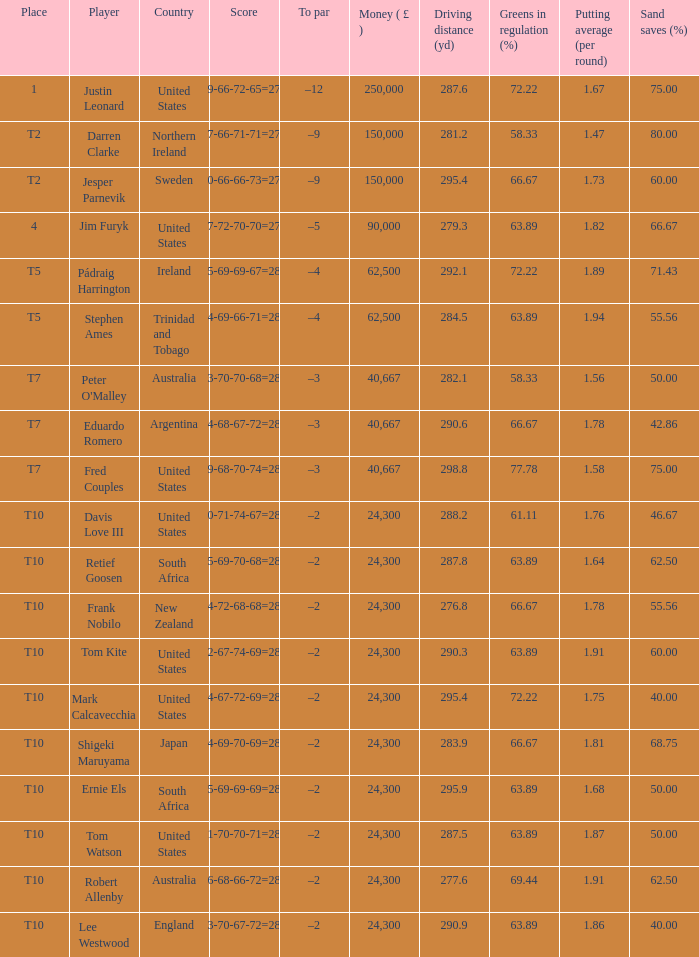What is the money won by Frank Nobilo? 1.0. Could you parse the entire table? {'header': ['Place', 'Player', 'Country', 'Score', 'To par', 'Money ( £ )', 'Driving distance (yd)', 'Greens in regulation (%)', 'Putting average (per round)', 'Sand saves (%)'], 'rows': [['1', 'Justin Leonard', 'United States', '69-66-72-65=272', '–12', '250,000', '287.6', '72.22', '1.67', '75.00'], ['T2', 'Darren Clarke', 'Northern Ireland', '67-66-71-71=275', '–9', '150,000', '281.2', '58.33', '1.47', '80.00'], ['T2', 'Jesper Parnevik', 'Sweden', '70-66-66-73=275', '–9', '150,000', '295.4', '66.67', '1.73', '60.00'], ['4', 'Jim Furyk', 'United States', '67-72-70-70=279', '–5', '90,000', '279.3', '63.89', '1.82', '66.67'], ['T5', 'Pádraig Harrington', 'Ireland', '75-69-69-67=280', '–4', '62,500', '292.1', '72.22', '1.89', '71.43'], ['T5', 'Stephen Ames', 'Trinidad and Tobago', '74-69-66-71=280', '–4', '62,500', '284.5', '63.89', '1.94', '55.56'], ['T7', "Peter O'Malley", 'Australia', '73-70-70-68=281', '–3', '40,667', '282.1', '58.33', '1.56', '50.00'], ['T7', 'Eduardo Romero', 'Argentina', '74-68-67-72=281', '–3', '40,667', '290.6', '66.67', '1.78', '42.86'], ['T7', 'Fred Couples', 'United States', '69-68-70-74=281', '–3', '40,667', '298.8', '77.78', '1.58', '75.00'], ['T10', 'Davis Love III', 'United States', '70-71-74-67=282', '–2', '24,300', '288.2', '61.11', '1.76', '46.67'], ['T10', 'Retief Goosen', 'South Africa', '75-69-70-68=282', '–2', '24,300', '287.8', '63.89', '1.64', '62.50'], ['T10', 'Frank Nobilo', 'New Zealand', '74-72-68-68=282', '–2', '24,300', '276.8', '66.67', '1.78', '55.56'], ['T10', 'Tom Kite', 'United States', '72-67-74-69=282', '–2', '24,300', '290.3', '63.89', '1.91', '60.00'], ['T10', 'Mark Calcavecchia', 'United States', '74-67-72-69=282', '–2', '24,300', '295.4', '72.22', '1.75', '40.00'], ['T10', 'Shigeki Maruyama', 'Japan', '74-69-70-69=282', '–2', '24,300', '283.9', '66.67', '1.81', '68.75'], ['T10', 'Ernie Els', 'South Africa', '75-69-69-69=282', '–2', '24,300', '295.9', '63.89', '1.68', '50.00'], ['T10', 'Tom Watson', 'United States', '71-70-70-71=282', '–2', '24,300', '287.5', '63.89', '1.87', '50.00'], ['T10', 'Robert Allenby', 'Australia', '76-68-66-72=282', '–2', '24,300', '277.6', '69.44', '1.91', '62.50'], ['T10', 'Lee Westwood', 'England', '73-70-67-72=282', '–2', '24,300', '290.9', '63.89', '1.86', '40.00']]} 